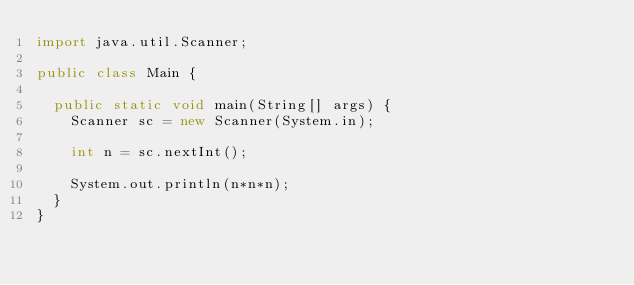<code> <loc_0><loc_0><loc_500><loc_500><_Java_>import java.util.Scanner;

public class Main {

  public static void main(String[] args) {
    Scanner sc = new Scanner(System.in);

    int n = sc.nextInt();

    System.out.println(n*n*n);
  }
}</code> 